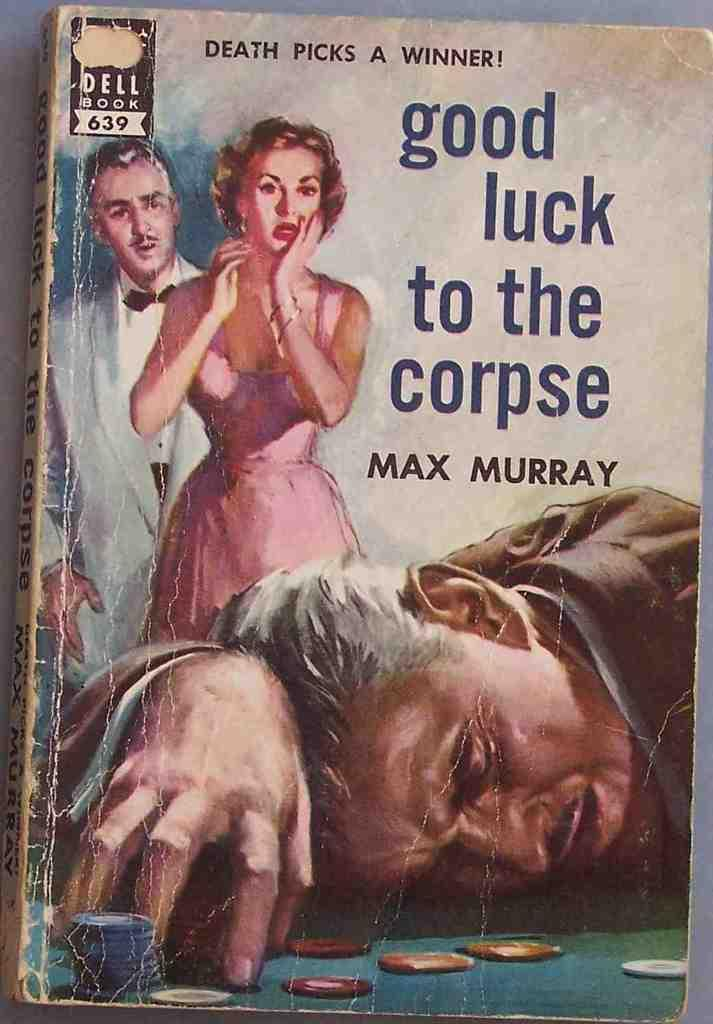<image>
Summarize the visual content of the image. The fronOld book good luck to the corpse by Max Murray with a man passed out on a gambling table and woman and man looking in shock at him. 